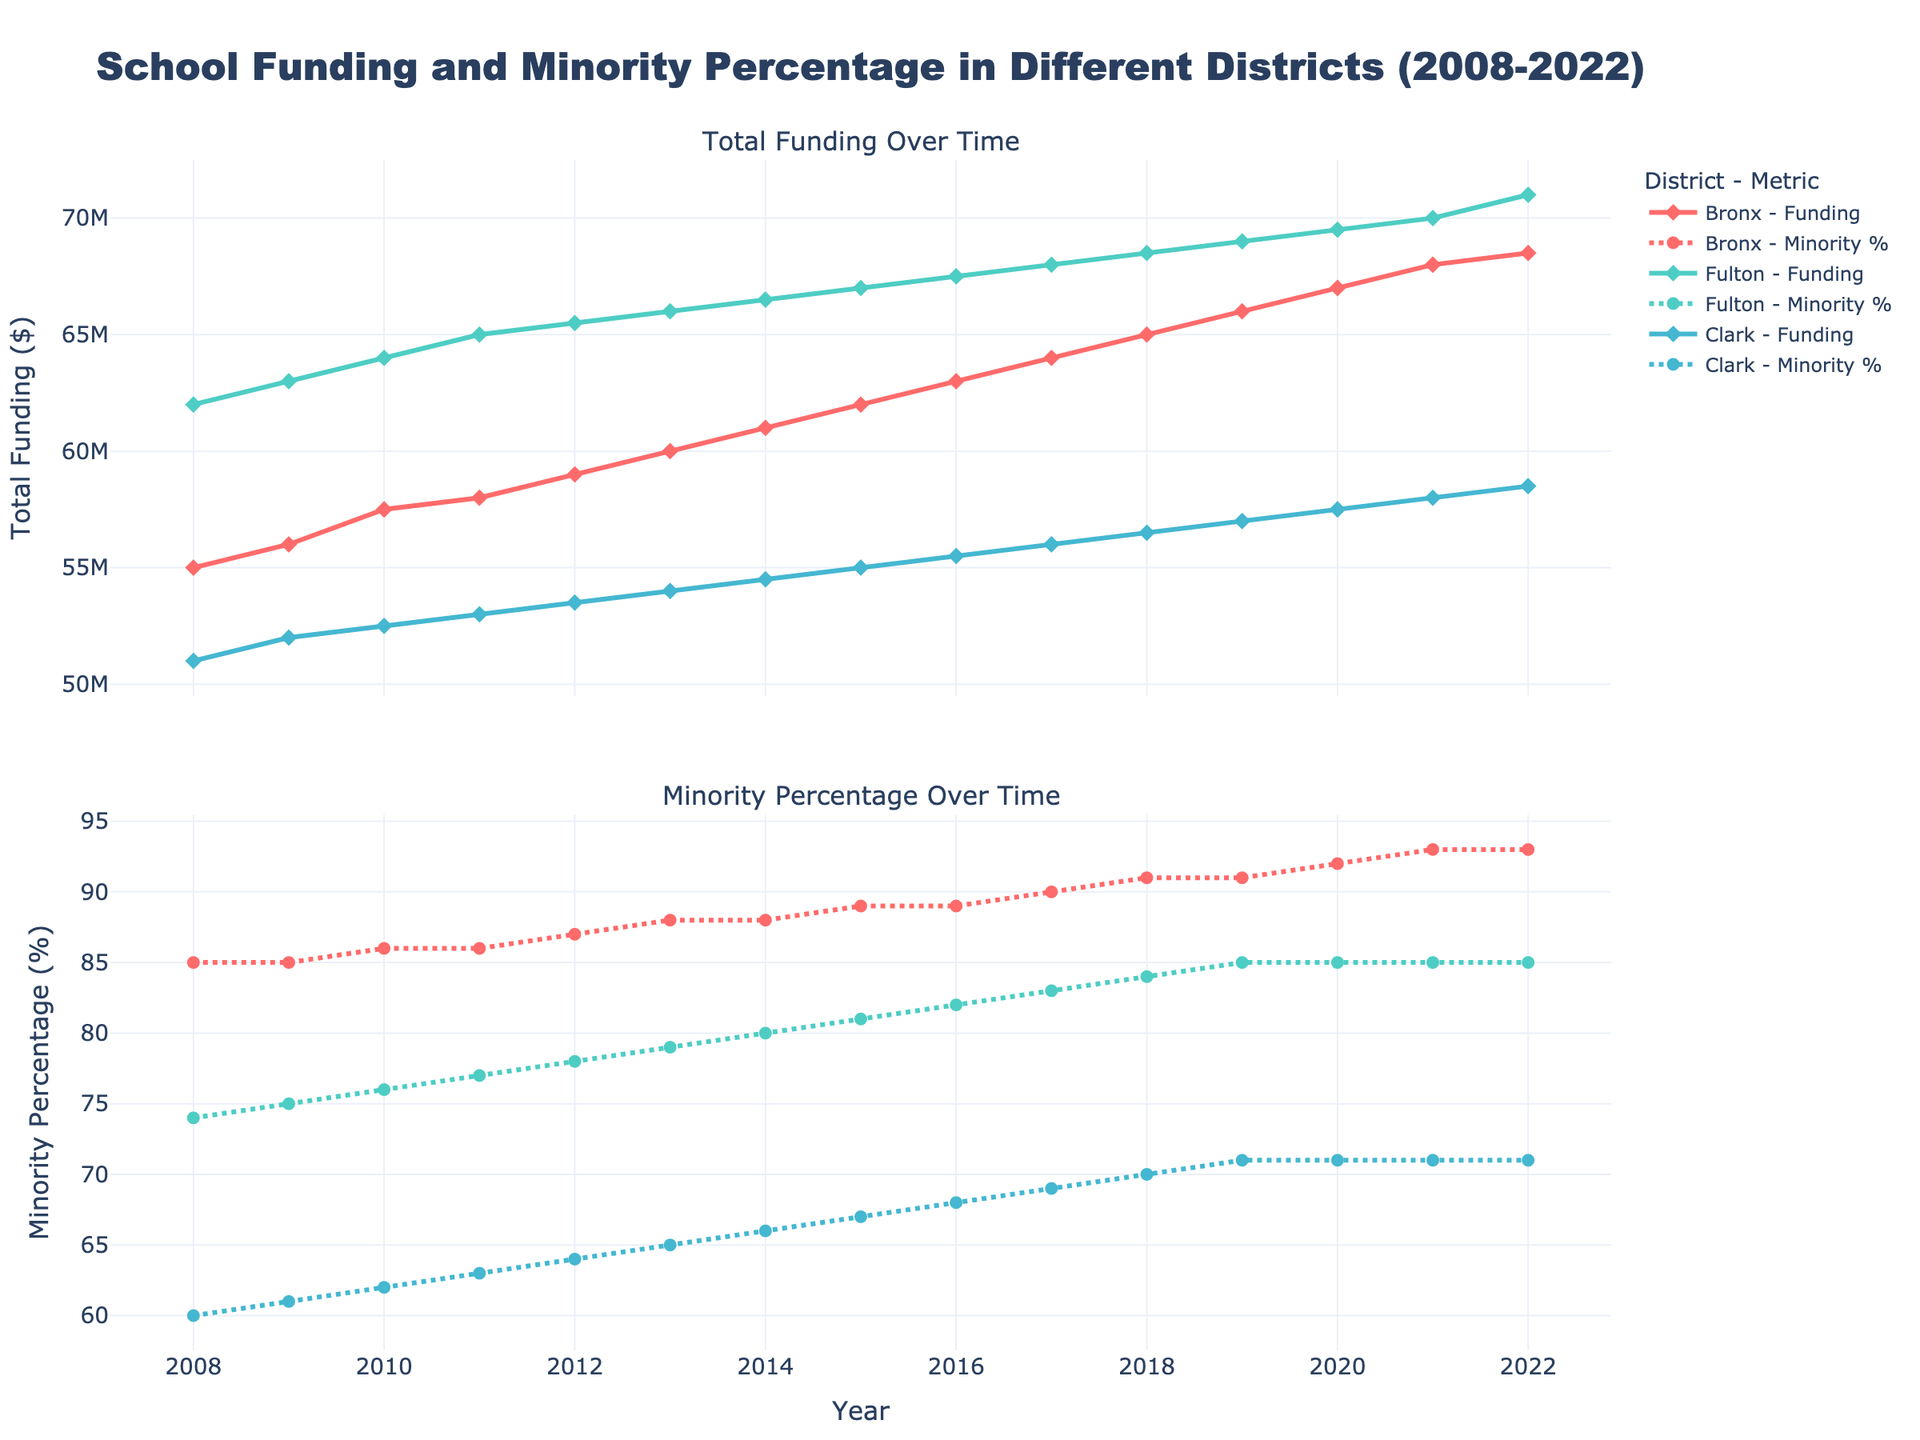How many overtime does has been an increase in annual funding for the Bronx from 2008 to 2022? To identify the increase in annual funding, subtract the funding amount in 2008 from the funding amount in 2022: ($68,500,000 in 2022) - ($55,000,000 in 2008) = $13,500,000.
Answer: $13,500,000 Which district had the highest total funding allocation in 2022? Compare the funding allocations of all districts in 2022: Bronx ($68,500,000), Fulton ($71,000,000), Clark ($58,500,000). Fulton had the highest funding allocation in 2022.
Answer: Fulton How has the minority percentage changed in Clark, Nevada from 2008 to 2022? Look at the minority percentage for Clark, Nevada in 2008 which is 60% and in 2022 which is 71%. The change is calculated as 71% - 60% = 11%.
Answer: 11% Which district shows the most consistent increase in total funding over the years? To find consistency, look at the trend lines of total funding for each district. The Bronx, New York shows a consistent gradual increase compared to Fulton, Georgia and Clark, Nevada.
Answer: Bronx, New York Is there a correlation between the total funding and the minority percentage in any of the districts? Comparing the lines plotted for both total funding and minority percentage for each district: Bronx shows a consistent increase in both parameters over the years, suggesting a positive correlation.
Answer: Yes, Bronx How much did the funding increase for Fulton, Georgia from 2010 to 2020? Subtract the funding amount in 2010 from the funding amount in 2020 for Fulton, Georgia: ($69,500,000 in 2020) - ($64,000,000 in 2010) = $5,500,000.
Answer: $5,500,000 What was the trend in minority percentage for Bronx, New York from 2008 to 2022? Observing the trend line for minority percentage in Bronx from 2008 (85%) to 2022 (93%), there is a consistent increase.
Answer: Increasing Which district had the least increase in total funding from 2008 to 2022? The increase in funding for each district is calculated as follows: Bronx ($68,500,000 - $55,000,000 = $13,500,000), Fulton ($71,000,000 - $62,000,000 = $9,000,000), Clark ($58,500,000 - $51,000,000 = $7,500,000). Clark had the least increase.
Answer: Clark Did any districts have periods where their funding did not increase? Analyze the trend lines of total funding for each district to identify any periods where funding remained constant. All districts show consistent, albeit varying, increases without periods of stagnation.
Answer: No Between Fulton, Georgia and Clark, Nevada, which district had a higher minority percentage throughout most of the years? By comparing the plotted percentage lines of both districts over the years, it is evident that Fulton, Georgia had a higher minority percentage consistently compared to Clark, Nevada.
Answer: Fulton, Georgia 